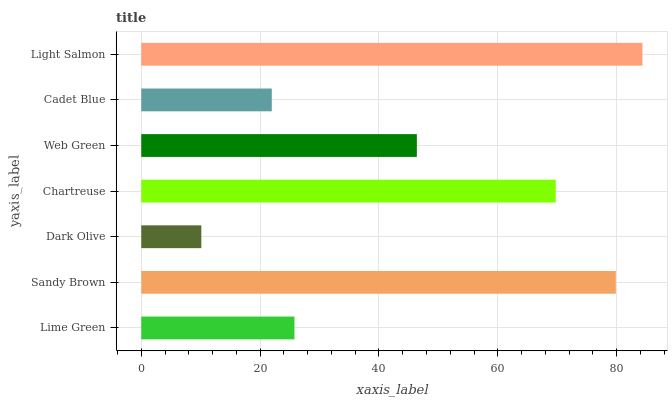Is Dark Olive the minimum?
Answer yes or no. Yes. Is Light Salmon the maximum?
Answer yes or no. Yes. Is Sandy Brown the minimum?
Answer yes or no. No. Is Sandy Brown the maximum?
Answer yes or no. No. Is Sandy Brown greater than Lime Green?
Answer yes or no. Yes. Is Lime Green less than Sandy Brown?
Answer yes or no. Yes. Is Lime Green greater than Sandy Brown?
Answer yes or no. No. Is Sandy Brown less than Lime Green?
Answer yes or no. No. Is Web Green the high median?
Answer yes or no. Yes. Is Web Green the low median?
Answer yes or no. Yes. Is Cadet Blue the high median?
Answer yes or no. No. Is Light Salmon the low median?
Answer yes or no. No. 